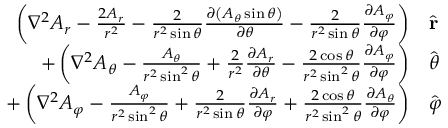<formula> <loc_0><loc_0><loc_500><loc_500>{ \begin{array} { r l } { \left ( \nabla ^ { 2 } A _ { r } - { \frac { 2 A _ { r } } { r ^ { 2 } } } - { \frac { 2 } { r ^ { 2 } \sin \theta } } { \frac { \partial \left ( A _ { \theta } \sin \theta \right ) } { \partial \theta } } - { \frac { 2 } { r ^ { 2 } \sin \theta } } { \frac { \partial A _ { \varphi } } { \partial \varphi } } \right ) } & { { \hat { r } } } \\ { + \left ( \nabla ^ { 2 } A _ { \theta } - { \frac { A _ { \theta } } { r ^ { 2 } \sin ^ { 2 } \theta } } + { \frac { 2 } { r ^ { 2 } } } { \frac { \partial A _ { r } } { \partial \theta } } - { \frac { 2 \cos \theta } { r ^ { 2 } \sin ^ { 2 } \theta } } { \frac { \partial A _ { \varphi } } { \partial \varphi } } \right ) } & { { \hat { \theta } } } \\ { + \left ( \nabla ^ { 2 } A _ { \varphi } - { \frac { A _ { \varphi } } { r ^ { 2 } \sin ^ { 2 } \theta } } + { \frac { 2 } { r ^ { 2 } \sin \theta } } { \frac { \partial A _ { r } } { \partial \varphi } } + { \frac { 2 \cos \theta } { r ^ { 2 } \sin ^ { 2 } \theta } } { \frac { \partial A _ { \theta } } { \partial \varphi } } \right ) } & { { \hat { \varphi } } } \end{array} }</formula> 